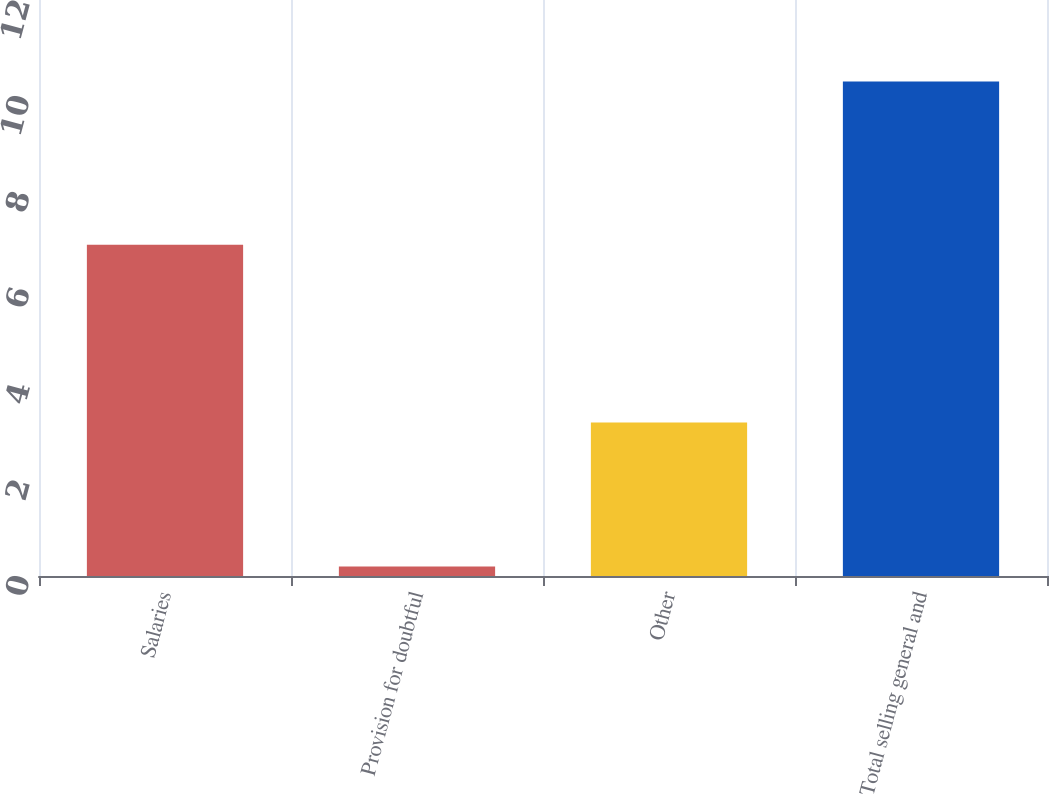Convert chart to OTSL. <chart><loc_0><loc_0><loc_500><loc_500><bar_chart><fcel>Salaries<fcel>Provision for doubtful<fcel>Other<fcel>Total selling general and<nl><fcel>6.9<fcel>0.2<fcel>3.2<fcel>10.3<nl></chart> 